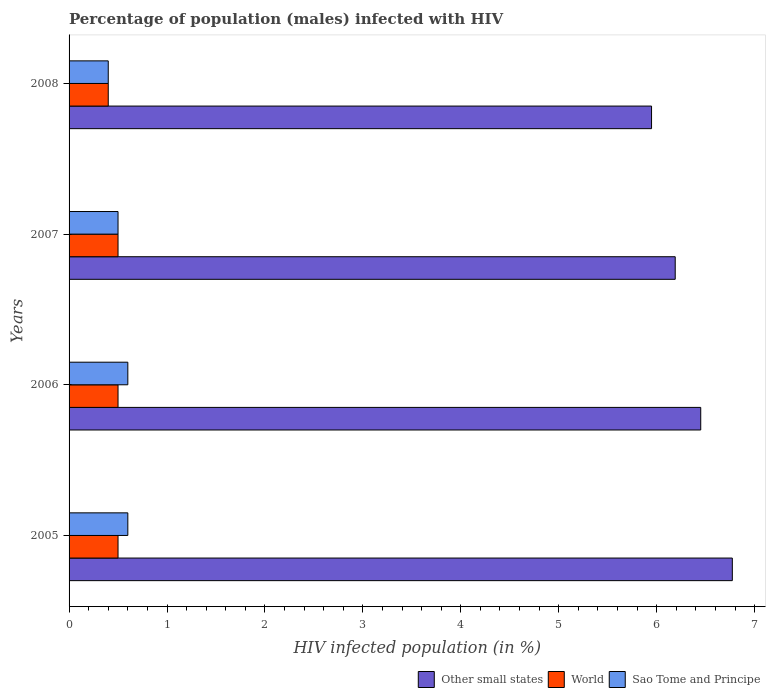How many groups of bars are there?
Keep it short and to the point. 4. Are the number of bars on each tick of the Y-axis equal?
Provide a short and direct response. Yes. How many bars are there on the 1st tick from the top?
Your answer should be compact. 3. What is the percentage of HIV infected male population in Sao Tome and Principe in 2008?
Your response must be concise. 0.4. Across all years, what is the minimum percentage of HIV infected male population in Other small states?
Offer a very short reply. 5.95. In which year was the percentage of HIV infected male population in Sao Tome and Principe maximum?
Make the answer very short. 2005. In which year was the percentage of HIV infected male population in Other small states minimum?
Keep it short and to the point. 2008. What is the difference between the percentage of HIV infected male population in World in 2006 and the percentage of HIV infected male population in Other small states in 2007?
Your response must be concise. -5.69. What is the average percentage of HIV infected male population in Sao Tome and Principe per year?
Provide a succinct answer. 0.53. In the year 2005, what is the difference between the percentage of HIV infected male population in Sao Tome and Principe and percentage of HIV infected male population in Other small states?
Give a very brief answer. -6.17. What is the ratio of the percentage of HIV infected male population in Other small states in 2007 to that in 2008?
Offer a terse response. 1.04. What is the difference between the highest and the lowest percentage of HIV infected male population in Sao Tome and Principe?
Offer a terse response. 0.2. In how many years, is the percentage of HIV infected male population in Sao Tome and Principe greater than the average percentage of HIV infected male population in Sao Tome and Principe taken over all years?
Ensure brevity in your answer.  2. Is the sum of the percentage of HIV infected male population in Other small states in 2007 and 2008 greater than the maximum percentage of HIV infected male population in World across all years?
Give a very brief answer. Yes. What does the 3rd bar from the bottom in 2005 represents?
Ensure brevity in your answer.  Sao Tome and Principe. Are all the bars in the graph horizontal?
Your answer should be compact. Yes. How many years are there in the graph?
Give a very brief answer. 4. Are the values on the major ticks of X-axis written in scientific E-notation?
Keep it short and to the point. No. Does the graph contain any zero values?
Your response must be concise. No. Does the graph contain grids?
Provide a short and direct response. No. How many legend labels are there?
Ensure brevity in your answer.  3. What is the title of the graph?
Ensure brevity in your answer.  Percentage of population (males) infected with HIV. Does "Sub-Saharan Africa (developing only)" appear as one of the legend labels in the graph?
Provide a short and direct response. No. What is the label or title of the X-axis?
Offer a terse response. HIV infected population (in %). What is the label or title of the Y-axis?
Give a very brief answer. Years. What is the HIV infected population (in %) of Other small states in 2005?
Offer a terse response. 6.77. What is the HIV infected population (in %) in World in 2005?
Give a very brief answer. 0.5. What is the HIV infected population (in %) of Sao Tome and Principe in 2005?
Your answer should be compact. 0.6. What is the HIV infected population (in %) in Other small states in 2006?
Your response must be concise. 6.45. What is the HIV infected population (in %) in World in 2006?
Make the answer very short. 0.5. What is the HIV infected population (in %) in Sao Tome and Principe in 2006?
Your response must be concise. 0.6. What is the HIV infected population (in %) of Other small states in 2007?
Make the answer very short. 6.19. What is the HIV infected population (in %) in World in 2007?
Provide a short and direct response. 0.5. What is the HIV infected population (in %) of Other small states in 2008?
Provide a succinct answer. 5.95. What is the HIV infected population (in %) of World in 2008?
Ensure brevity in your answer.  0.4. Across all years, what is the maximum HIV infected population (in %) of Other small states?
Give a very brief answer. 6.77. Across all years, what is the minimum HIV infected population (in %) in Other small states?
Provide a succinct answer. 5.95. What is the total HIV infected population (in %) in Other small states in the graph?
Give a very brief answer. 25.36. What is the difference between the HIV infected population (in %) in Other small states in 2005 and that in 2006?
Keep it short and to the point. 0.32. What is the difference between the HIV infected population (in %) of World in 2005 and that in 2006?
Provide a succinct answer. 0. What is the difference between the HIV infected population (in %) in Sao Tome and Principe in 2005 and that in 2006?
Your response must be concise. 0. What is the difference between the HIV infected population (in %) in Other small states in 2005 and that in 2007?
Your answer should be compact. 0.58. What is the difference between the HIV infected population (in %) in World in 2005 and that in 2007?
Your answer should be very brief. 0. What is the difference between the HIV infected population (in %) of Sao Tome and Principe in 2005 and that in 2007?
Your answer should be compact. 0.1. What is the difference between the HIV infected population (in %) of Other small states in 2005 and that in 2008?
Give a very brief answer. 0.82. What is the difference between the HIV infected population (in %) of Other small states in 2006 and that in 2007?
Your answer should be very brief. 0.26. What is the difference between the HIV infected population (in %) in World in 2006 and that in 2007?
Your answer should be compact. 0. What is the difference between the HIV infected population (in %) of Other small states in 2006 and that in 2008?
Ensure brevity in your answer.  0.5. What is the difference between the HIV infected population (in %) in World in 2006 and that in 2008?
Your response must be concise. 0.1. What is the difference between the HIV infected population (in %) in Other small states in 2007 and that in 2008?
Keep it short and to the point. 0.24. What is the difference between the HIV infected population (in %) of Sao Tome and Principe in 2007 and that in 2008?
Keep it short and to the point. 0.1. What is the difference between the HIV infected population (in %) in Other small states in 2005 and the HIV infected population (in %) in World in 2006?
Ensure brevity in your answer.  6.27. What is the difference between the HIV infected population (in %) of Other small states in 2005 and the HIV infected population (in %) of Sao Tome and Principe in 2006?
Ensure brevity in your answer.  6.17. What is the difference between the HIV infected population (in %) in World in 2005 and the HIV infected population (in %) in Sao Tome and Principe in 2006?
Provide a succinct answer. -0.1. What is the difference between the HIV infected population (in %) of Other small states in 2005 and the HIV infected population (in %) of World in 2007?
Offer a terse response. 6.27. What is the difference between the HIV infected population (in %) in Other small states in 2005 and the HIV infected population (in %) in Sao Tome and Principe in 2007?
Offer a very short reply. 6.27. What is the difference between the HIV infected population (in %) in World in 2005 and the HIV infected population (in %) in Sao Tome and Principe in 2007?
Offer a very short reply. 0. What is the difference between the HIV infected population (in %) in Other small states in 2005 and the HIV infected population (in %) in World in 2008?
Provide a succinct answer. 6.37. What is the difference between the HIV infected population (in %) of Other small states in 2005 and the HIV infected population (in %) of Sao Tome and Principe in 2008?
Offer a terse response. 6.37. What is the difference between the HIV infected population (in %) of Other small states in 2006 and the HIV infected population (in %) of World in 2007?
Your answer should be very brief. 5.95. What is the difference between the HIV infected population (in %) of Other small states in 2006 and the HIV infected population (in %) of Sao Tome and Principe in 2007?
Ensure brevity in your answer.  5.95. What is the difference between the HIV infected population (in %) in World in 2006 and the HIV infected population (in %) in Sao Tome and Principe in 2007?
Provide a short and direct response. 0. What is the difference between the HIV infected population (in %) of Other small states in 2006 and the HIV infected population (in %) of World in 2008?
Ensure brevity in your answer.  6.05. What is the difference between the HIV infected population (in %) in Other small states in 2006 and the HIV infected population (in %) in Sao Tome and Principe in 2008?
Your response must be concise. 6.05. What is the difference between the HIV infected population (in %) in Other small states in 2007 and the HIV infected population (in %) in World in 2008?
Your response must be concise. 5.79. What is the difference between the HIV infected population (in %) of Other small states in 2007 and the HIV infected population (in %) of Sao Tome and Principe in 2008?
Your answer should be compact. 5.79. What is the difference between the HIV infected population (in %) of World in 2007 and the HIV infected population (in %) of Sao Tome and Principe in 2008?
Give a very brief answer. 0.1. What is the average HIV infected population (in %) in Other small states per year?
Ensure brevity in your answer.  6.34. What is the average HIV infected population (in %) in World per year?
Make the answer very short. 0.47. What is the average HIV infected population (in %) of Sao Tome and Principe per year?
Ensure brevity in your answer.  0.53. In the year 2005, what is the difference between the HIV infected population (in %) of Other small states and HIV infected population (in %) of World?
Offer a very short reply. 6.27. In the year 2005, what is the difference between the HIV infected population (in %) of Other small states and HIV infected population (in %) of Sao Tome and Principe?
Ensure brevity in your answer.  6.17. In the year 2005, what is the difference between the HIV infected population (in %) in World and HIV infected population (in %) in Sao Tome and Principe?
Your answer should be compact. -0.1. In the year 2006, what is the difference between the HIV infected population (in %) in Other small states and HIV infected population (in %) in World?
Provide a short and direct response. 5.95. In the year 2006, what is the difference between the HIV infected population (in %) in Other small states and HIV infected population (in %) in Sao Tome and Principe?
Make the answer very short. 5.85. In the year 2007, what is the difference between the HIV infected population (in %) in Other small states and HIV infected population (in %) in World?
Provide a short and direct response. 5.69. In the year 2007, what is the difference between the HIV infected population (in %) of Other small states and HIV infected population (in %) of Sao Tome and Principe?
Give a very brief answer. 5.69. In the year 2008, what is the difference between the HIV infected population (in %) in Other small states and HIV infected population (in %) in World?
Provide a succinct answer. 5.55. In the year 2008, what is the difference between the HIV infected population (in %) of Other small states and HIV infected population (in %) of Sao Tome and Principe?
Your answer should be compact. 5.55. In the year 2008, what is the difference between the HIV infected population (in %) of World and HIV infected population (in %) of Sao Tome and Principe?
Provide a succinct answer. 0. What is the ratio of the HIV infected population (in %) of Other small states in 2005 to that in 2006?
Offer a terse response. 1.05. What is the ratio of the HIV infected population (in %) of Other small states in 2005 to that in 2007?
Provide a short and direct response. 1.09. What is the ratio of the HIV infected population (in %) in World in 2005 to that in 2007?
Provide a short and direct response. 1. What is the ratio of the HIV infected population (in %) in Other small states in 2005 to that in 2008?
Make the answer very short. 1.14. What is the ratio of the HIV infected population (in %) in World in 2005 to that in 2008?
Provide a short and direct response. 1.25. What is the ratio of the HIV infected population (in %) of Sao Tome and Principe in 2005 to that in 2008?
Keep it short and to the point. 1.5. What is the ratio of the HIV infected population (in %) of Other small states in 2006 to that in 2007?
Make the answer very short. 1.04. What is the ratio of the HIV infected population (in %) in Other small states in 2006 to that in 2008?
Ensure brevity in your answer.  1.08. What is the ratio of the HIV infected population (in %) in Sao Tome and Principe in 2006 to that in 2008?
Your response must be concise. 1.5. What is the ratio of the HIV infected population (in %) of Other small states in 2007 to that in 2008?
Your response must be concise. 1.04. What is the ratio of the HIV infected population (in %) in World in 2007 to that in 2008?
Your response must be concise. 1.25. What is the difference between the highest and the second highest HIV infected population (in %) of Other small states?
Give a very brief answer. 0.32. What is the difference between the highest and the second highest HIV infected population (in %) of World?
Your response must be concise. 0. What is the difference between the highest and the lowest HIV infected population (in %) of Other small states?
Offer a very short reply. 0.82. 